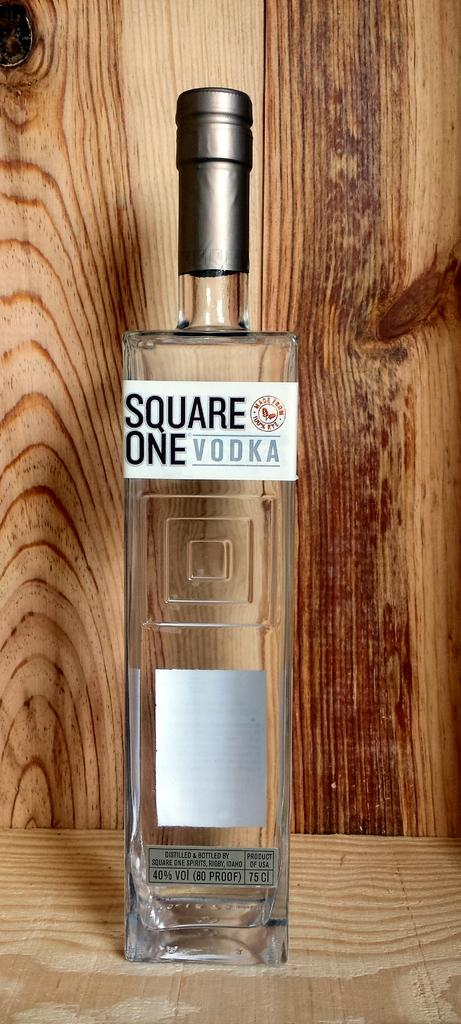Provide a one-sentence caption for the provided image. A BOTTLE OF VODKA THAT READS SQUARE ONE VODKA. 